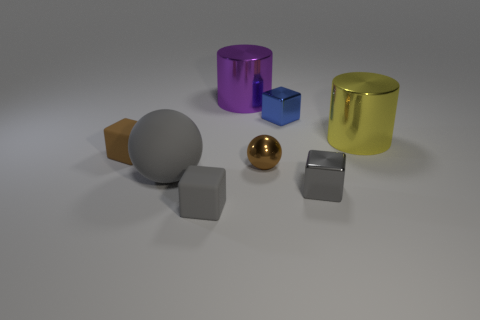There is a shiny cube in front of the big shiny cylinder right of the small sphere; how big is it? The shiny cube in front of the big shiny cylinder and to the right of the small sphere appears to be of moderate size in comparison to the other objects within the scene. Specifically, it is smaller than the large shiny cylinder but larger than the small sphere, indicating that it is of a medium size relative to the objects presented. 